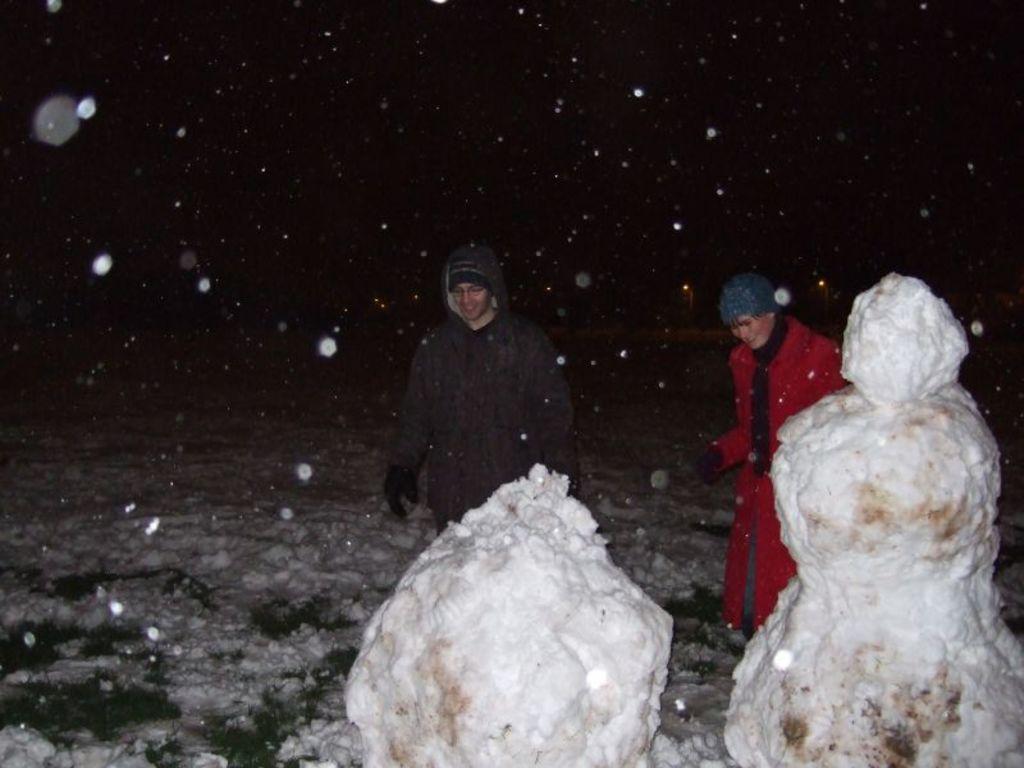In one or two sentences, can you explain what this image depicts? In this image I can see few snow dolls. In the background I can see two persons standing and the sky is in black color. 